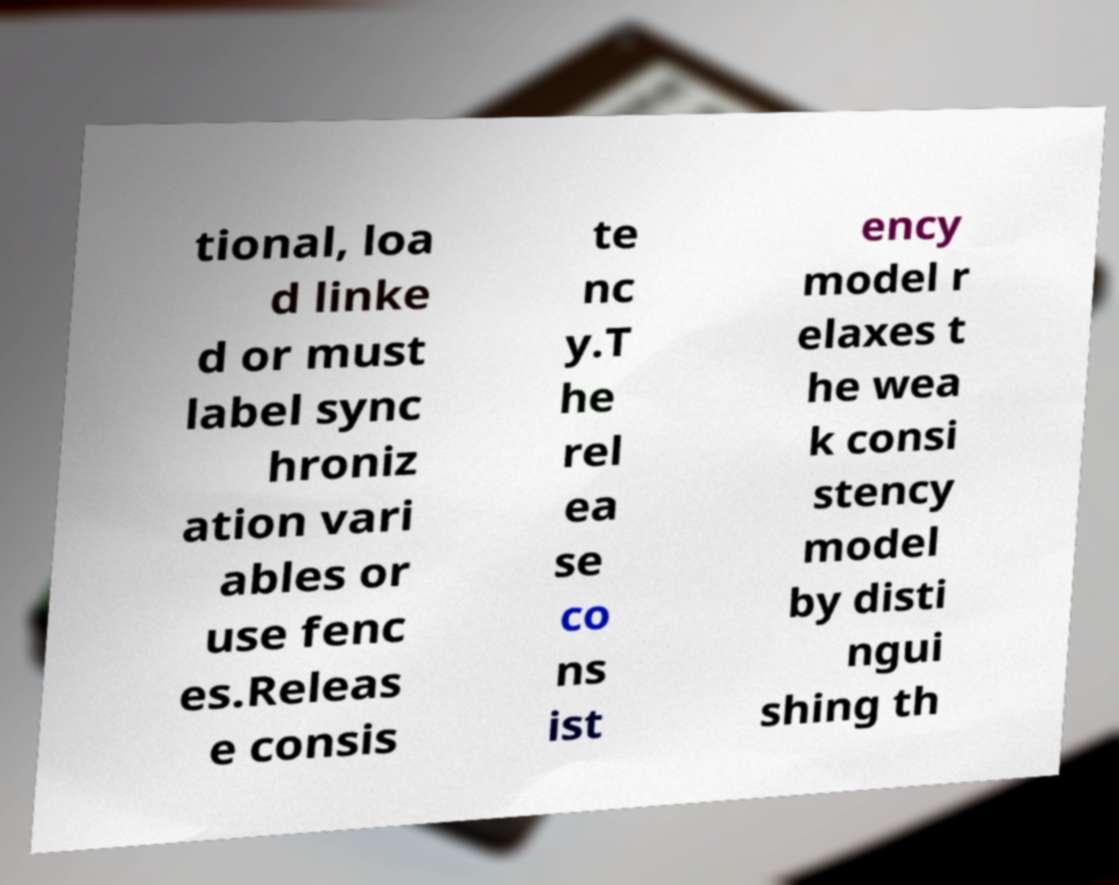Could you assist in decoding the text presented in this image and type it out clearly? tional, loa d linke d or must label sync hroniz ation vari ables or use fenc es.Releas e consis te nc y.T he rel ea se co ns ist ency model r elaxes t he wea k consi stency model by disti ngui shing th 